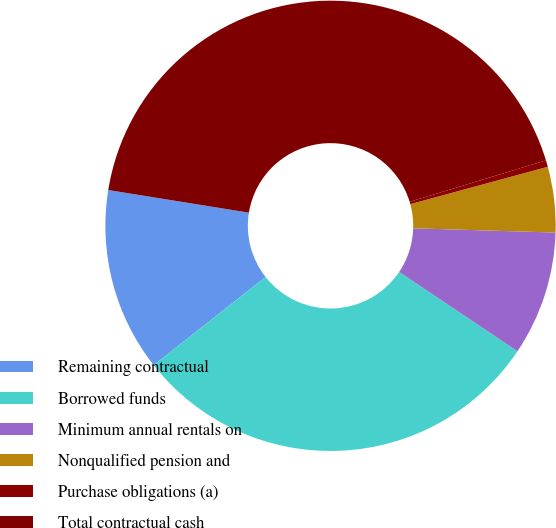Convert chart to OTSL. <chart><loc_0><loc_0><loc_500><loc_500><pie_chart><fcel>Remaining contractual<fcel>Borrowed funds<fcel>Minimum annual rentals on<fcel>Nonqualified pension and<fcel>Purchase obligations (a)<fcel>Total contractual cash<nl><fcel>13.16%<fcel>29.97%<fcel>8.93%<fcel>4.7%<fcel>0.47%<fcel>42.76%<nl></chart> 